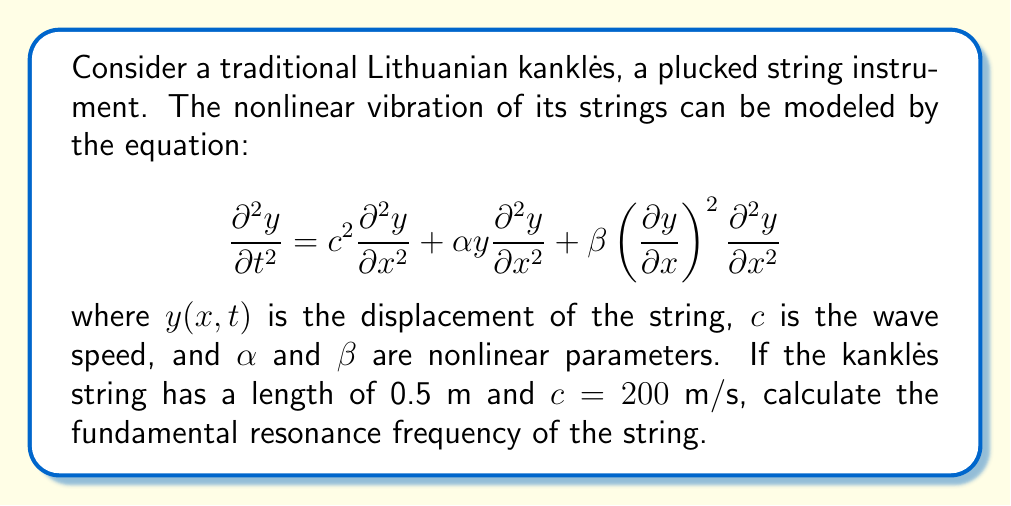Teach me how to tackle this problem. To solve this problem, we'll follow these steps:

1) First, we need to understand that the fundamental frequency of a string is related to its length and wave speed. In a linear system, this would be given by:

   $$f = \frac{c}{2L}$$

   where $f$ is the frequency, $c$ is the wave speed, and $L$ is the length of the string.

2) However, our system is nonlinear. The nonlinear terms in the equation ($\alpha y \frac{\partial^2 y}{\partial x^2}$ and $\beta \left(\frac{\partial y}{\partial x}\right)^2 \frac{\partial^2 y}{\partial x^2}$) will cause a shift in the resonance frequency.

3) For small amplitude vibrations, we can approximate the fundamental frequency using perturbation theory. The correction to the linear frequency is typically proportional to the square of the amplitude.

4) However, without specific information about the amplitude of vibration and the nonlinear parameters $\alpha$ and $\beta$, we cannot calculate this correction precisely.

5) Therefore, as a first approximation, we can use the linear formula to estimate the fundamental frequency:

   $$f \approx \frac{c}{2L} = \frac{200 \text{ m/s}}{2 \cdot 0.5 \text{ m}} = 200 \text{ Hz}$$

6) It's important to note that the actual resonance frequency will be slightly different due to the nonlinear effects, but this calculation gives us a good starting point for understanding the instrument's behavior.

7) In practice, a professional musician like yourself would tune the kanklės by ear or using a tuner, accounting for these nonlinear effects intuitively through experience.
Answer: $200 \text{ Hz}$ (approximate) 